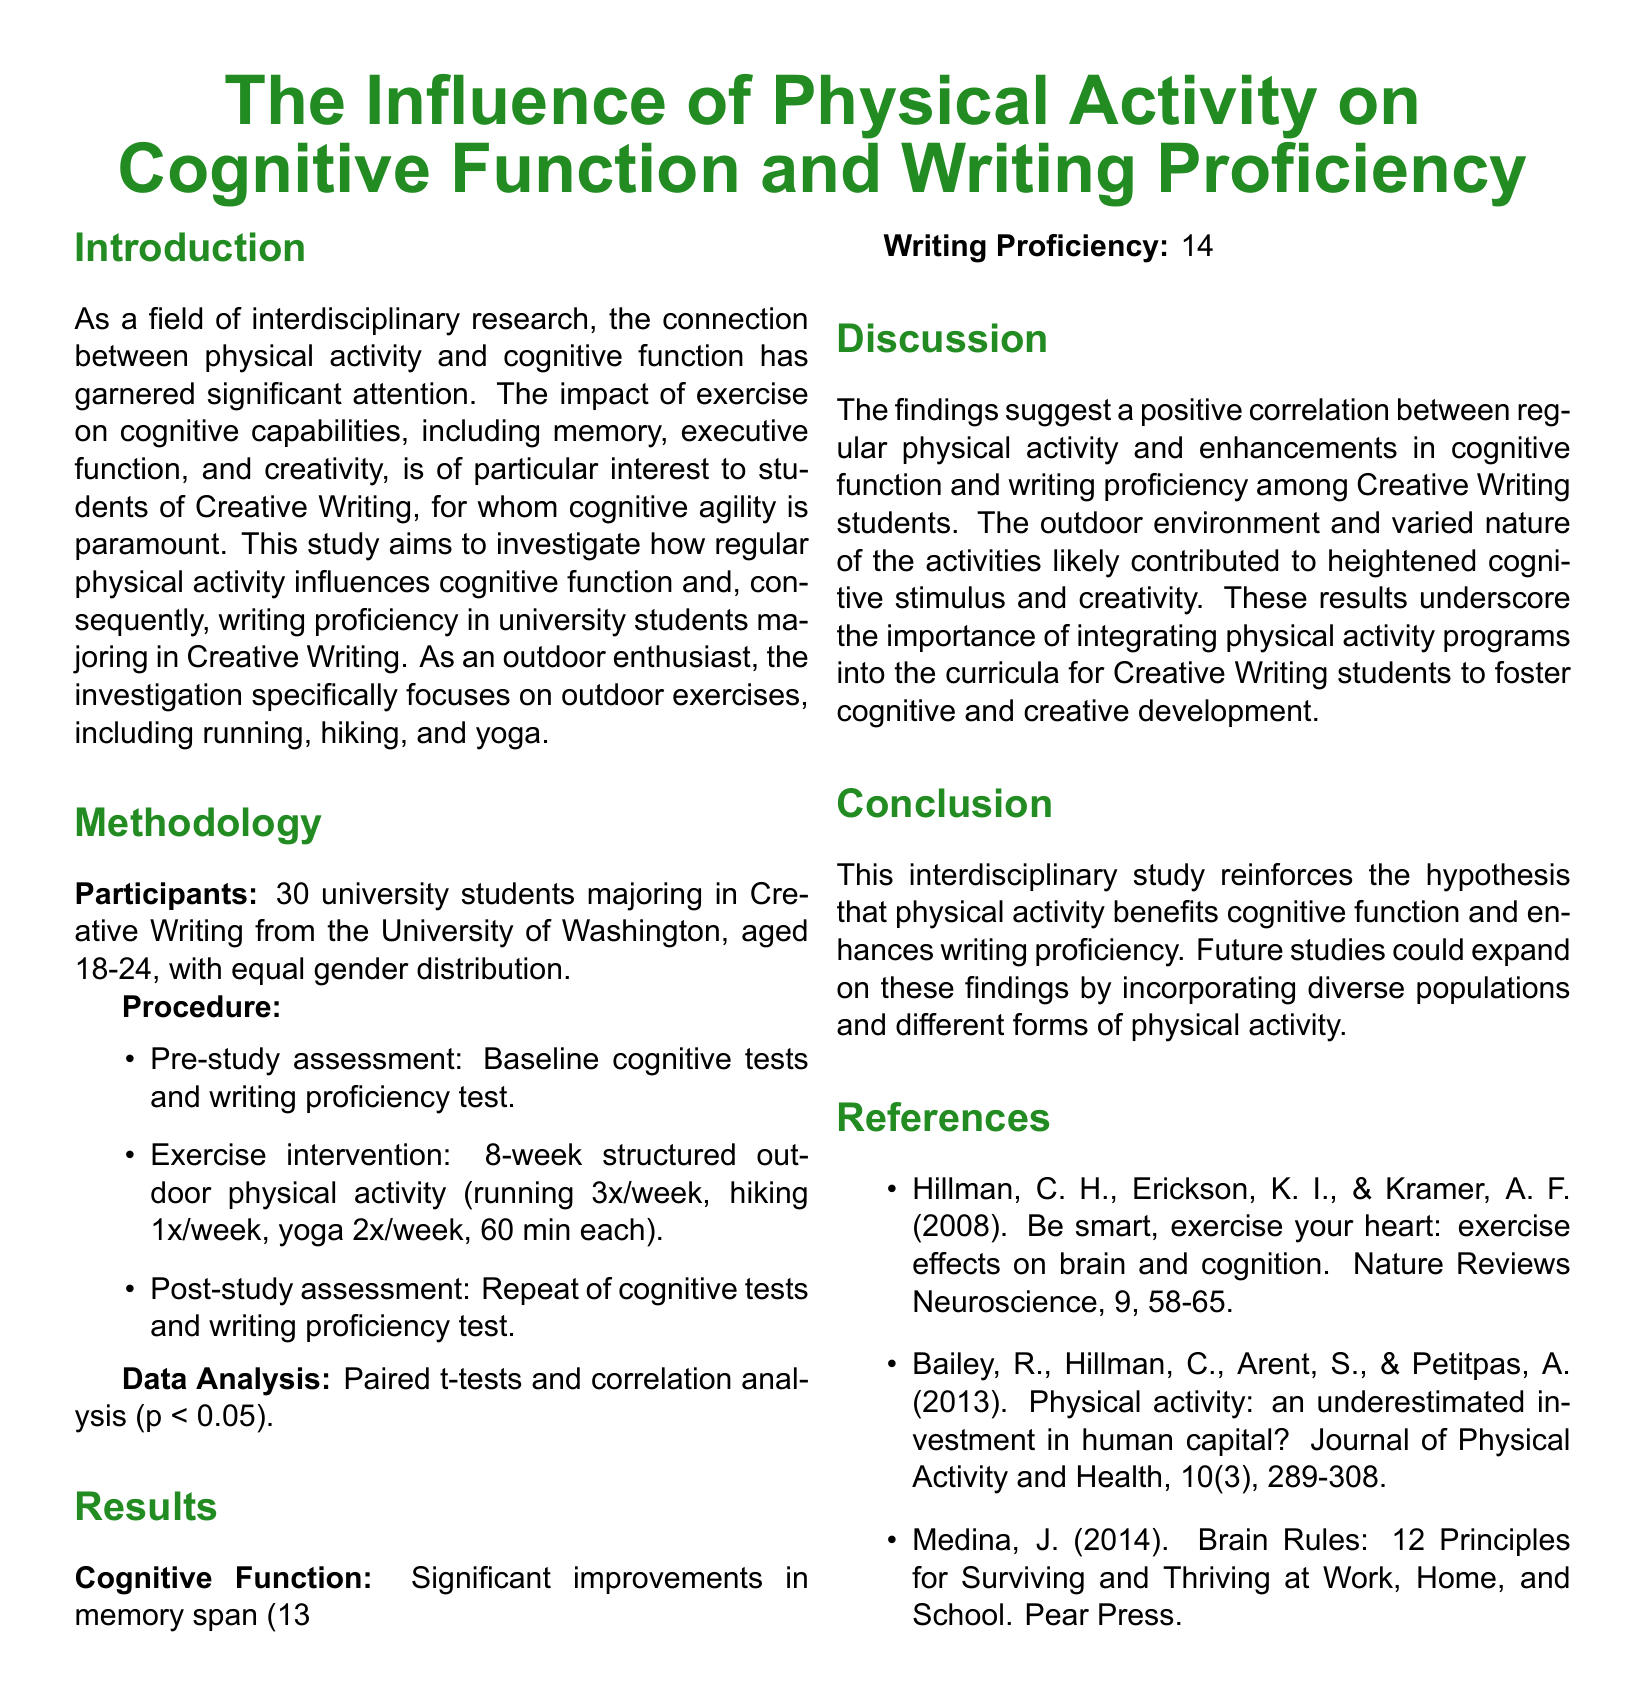What was the age range of the participants? The participants were aged 18-24 years old according to the data presented in the document.
Answer: 18-24 How many students participated in the study? The document states that there were 30 university students involved in this research.
Answer: 30 What was the percentage increase in memory span? The results section indicates a significant improvement in memory span with a 13% increase noted.
Answer: 13% Which types of outdoor exercises were included in the program? The methodology specifies that the structured outdoor physical activities included running, hiking, and yoga.
Answer: Running, hiking, yoga What was the overall average increase in writing proficiency scores? The report mentions a 14% average increase in overall writing proficiency scores as a significant finding.
Answer: 14% What statistical method was used to analyze the data? The document outlines that paired t-tests and correlation analysis were used to analyze the obtained results.
Answer: Paired t-tests and correlation analysis How long was the exercise intervention period? The methodology section specifies that the exercise intervention lasted for 8 weeks.
Answer: 8 weeks What could future studies expand upon according to the conclusion? The conclusion suggests that future studies could incorporate diverse populations and different forms of physical activity.
Answer: Diverse populations and different forms of physical activity What cognitive function improvement was measured by the Stroop Test? The results indicate that there was a 16% decrease in Stroop Test completion time, reflecting an improvement in executive function.
Answer: 16% What is the primary focus of this interdisciplinary study? The primary focus, as stated in the introduction, is to investigate how regular physical activity influences cognitive function and writing proficiency.
Answer: Influence of physical activity on cognitive function and writing proficiency 